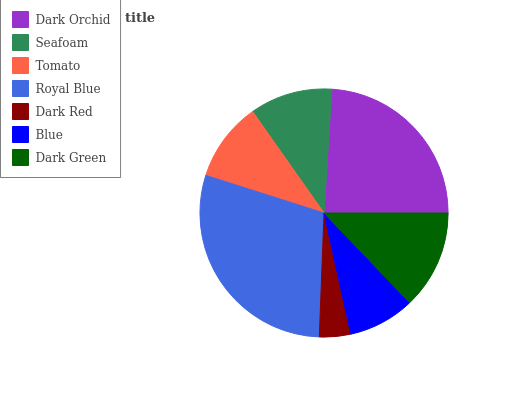Is Dark Red the minimum?
Answer yes or no. Yes. Is Royal Blue the maximum?
Answer yes or no. Yes. Is Seafoam the minimum?
Answer yes or no. No. Is Seafoam the maximum?
Answer yes or no. No. Is Dark Orchid greater than Seafoam?
Answer yes or no. Yes. Is Seafoam less than Dark Orchid?
Answer yes or no. Yes. Is Seafoam greater than Dark Orchid?
Answer yes or no. No. Is Dark Orchid less than Seafoam?
Answer yes or no. No. Is Seafoam the high median?
Answer yes or no. Yes. Is Seafoam the low median?
Answer yes or no. Yes. Is Dark Orchid the high median?
Answer yes or no. No. Is Tomato the low median?
Answer yes or no. No. 